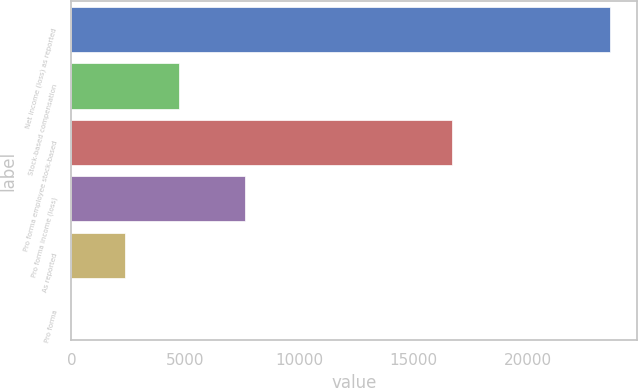Convert chart to OTSL. <chart><loc_0><loc_0><loc_500><loc_500><bar_chart><fcel>Net income (loss) as reported<fcel>Stock-based compensation<fcel>Pro forma employee stock-based<fcel>Pro forma income (loss)<fcel>As reported<fcel>Pro forma<nl><fcel>23589<fcel>4717.86<fcel>16665<fcel>7621<fcel>2358.97<fcel>0.08<nl></chart> 